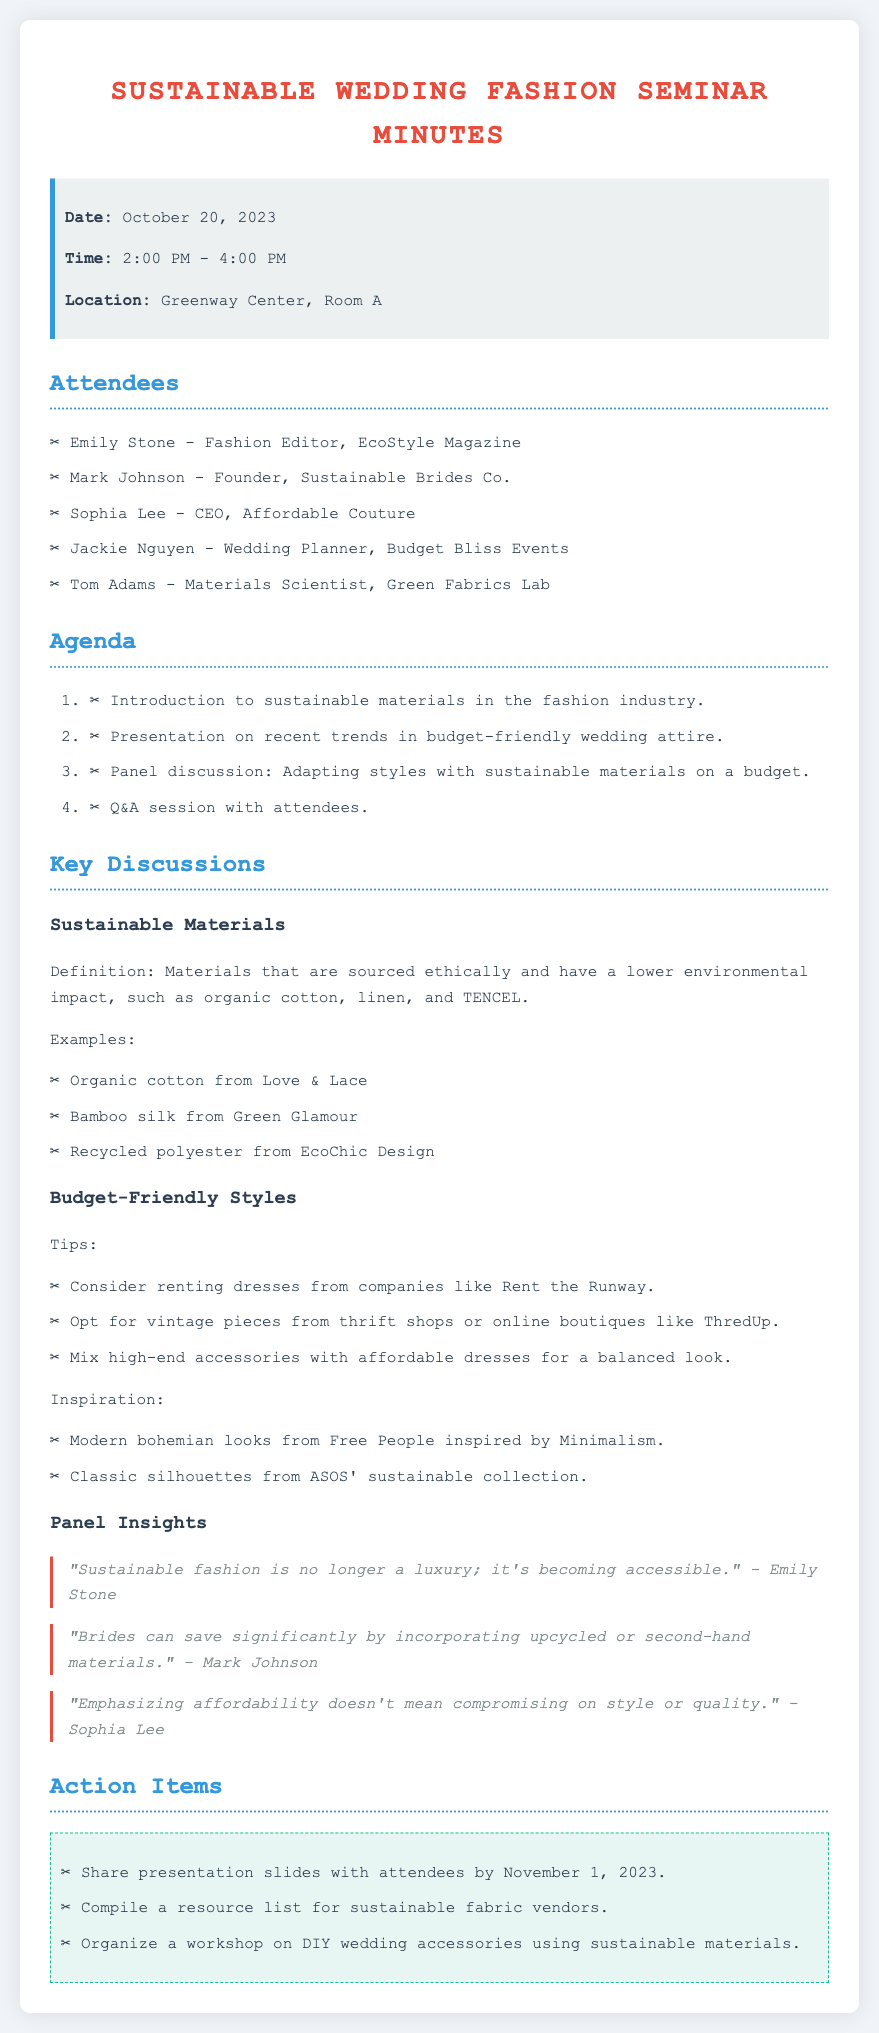What is the date of the seminar? The date of the seminar is clearly stated in the info box as October 20, 2023.
Answer: October 20, 2023 Who presented on the recent trends in budget-friendly wedding attire? The agenda indicates a presentation on budget-friendly wedding attire but does not specify a presenter, suggesting group contributions.
Answer: Not specified What time did the seminar start? The start time for the seminar is listed in the info box as 2:00 PM.
Answer: 2:00 PM Which material is highlighted as recycled in the seminar? The document lists recycled polyester from EcoChic Design as an example of sustainable materials discussed.
Answer: Recycled polyester What is one tip for finding affordable wedding attire? The key discussions include a tip to consider renting dresses from companies like Rent the Runway, highlighting the affordability aspect.
Answer: Renting dresses Who emphasized that sustainable fashion is becoming accessible? The quote from Emily Stone emphasizes that sustainable fashion is no longer a luxury; it's becoming accessible.
Answer: Emily Stone What is one action item mentioned in the seminar? The action items list includes sharing presentation slides with attendees by a specified date.
Answer: Share presentation slides What does Mark Johnson say about saving significantly for brides? Mark Johnson mentions that brides can save significantly by incorporating upcycled or second-hand materials in the panel insights.
Answer: Upcycled or second-hand materials Which company is associated with the CEO Sophia Lee? Sophia Lee is identified in the attendees’ list as the CEO of Affordable Couture.
Answer: Affordable Couture 